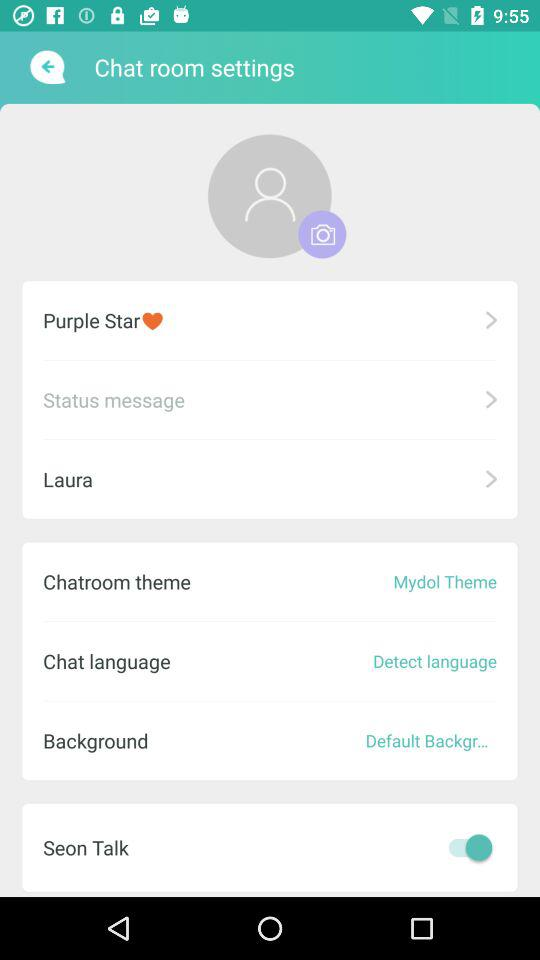Which tab is selected?
When the provided information is insufficient, respond with <no answer>. <no answer> 